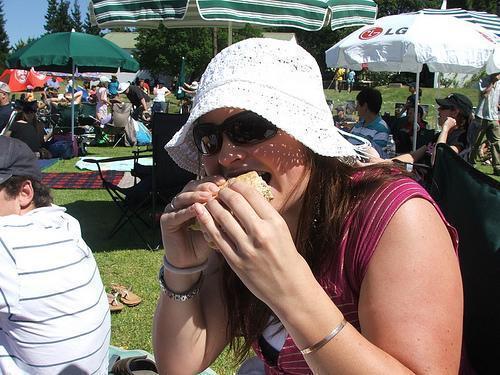What is the woman doing with the object in her hand?
Indicate the correct response and explain using: 'Answer: answer
Rationale: rationale.'
Options: Throwing it, passing it, trading it, eating it. Answer: eating it.
Rationale: The woman is eating. 